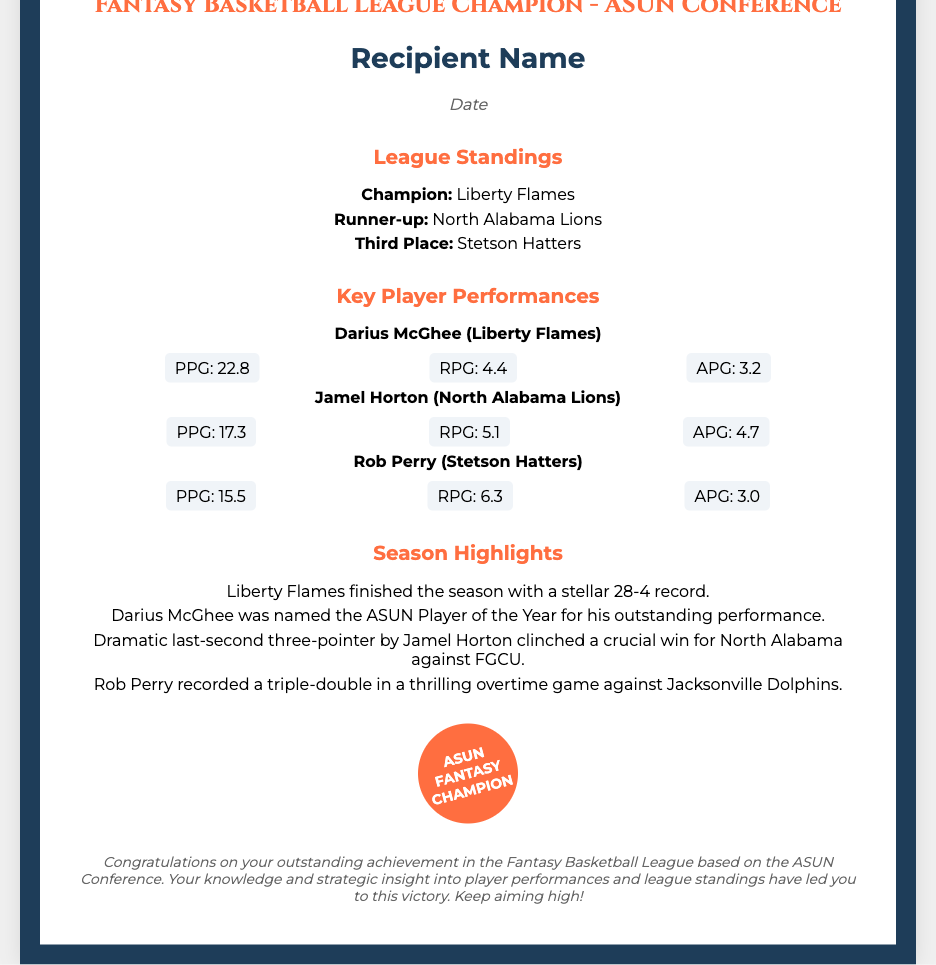What is the title of the certificate? The title of the certificate is presented at the top and denotes the achievement recognized, which is for Fantasy Basketball League Champion in the ASUN Conference.
Answer: Certificate of Achievement Who is the champion of the league? The document lists the champion under the standings section clearly identifying the top team for the ASUN Fantasy Basketball League.
Answer: Liberty Flames What was Darius McGhee's points per game? The performance section provides specific statistics for each key player, focusing on their scoring metrics, including points per game.
Answer: 22.8 How many total wins did Liberty Flames achieve this season? The season highlights summarize the performance of the champion team, providing their win-loss record for the entire season.
Answer: 28 Which player recorded a triple-double? The highlights mention a specific achievement of one key player during a notable game, indicating a significant performance milestone.
Answer: Rob Perry When was the certificate awarded? The date section indicates when the certificate was given, which is traditionally required information included in certificates like this.
Answer: Date What was the outcome of the last-second play by Jamel Horton? The highlights detail a notable moment in a game involving a specific player, showcasing his impact in a crucial match situation.
Answer: Clinched a win How many teams were mentioned in the standings? The standings section lists the ranks of the top teams, referring directly to the competitive structure of the league in the document.
Answer: Three What is included in the footer? The footer provides a congratulatory message that reflects on the accomplishment obtained through participation and knowledge of the league.
Answer: Congratulations on your outstanding achievement 